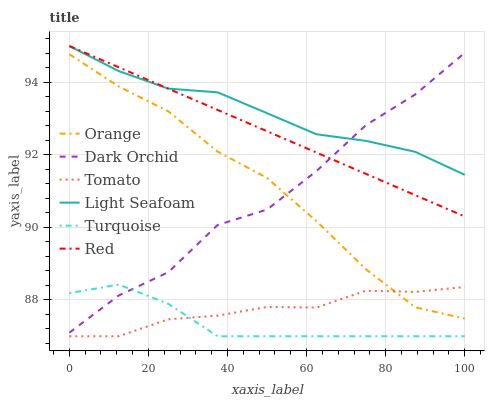Does Dark Orchid have the minimum area under the curve?
Answer yes or no. No. Does Dark Orchid have the maximum area under the curve?
Answer yes or no. No. Is Turquoise the smoothest?
Answer yes or no. No. Is Turquoise the roughest?
Answer yes or no. No. Does Dark Orchid have the lowest value?
Answer yes or no. No. Does Turquoise have the highest value?
Answer yes or no. No. Is Tomato less than Light Seafoam?
Answer yes or no. Yes. Is Light Seafoam greater than Turquoise?
Answer yes or no. Yes. Does Tomato intersect Light Seafoam?
Answer yes or no. No. 